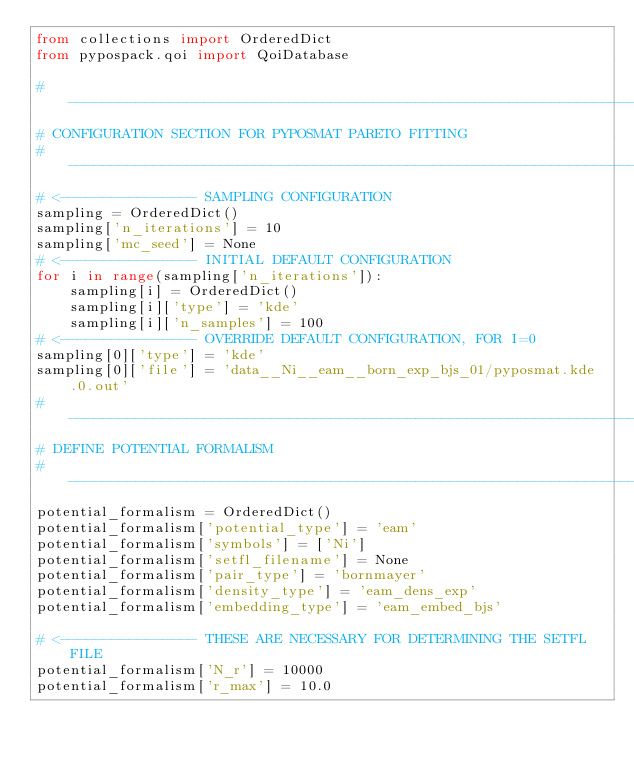<code> <loc_0><loc_0><loc_500><loc_500><_Python_>from collections import OrderedDict
from pypospack.qoi import QoiDatabase

#------------------------------------------------------------------------------
# CONFIGURATION SECTION FOR PYPOSMAT PARETO FITTING
#------------------------------------------------------------------------------
# <---------------- SAMPLING CONFIGURATION
sampling = OrderedDict()
sampling['n_iterations'] = 10
sampling['mc_seed'] = None
# <---------------- INITIAL DEFAULT CONFIGURATION
for i in range(sampling['n_iterations']):
    sampling[i] = OrderedDict()
    sampling[i]['type'] = 'kde'
    sampling[i]['n_samples'] = 100
# <---------------- OVERRIDE DEFAULT CONFIGURATION, FOR I=0
sampling[0]['type'] = 'kde'
sampling[0]['file'] = 'data__Ni__eam__born_exp_bjs_01/pyposmat.kde.0.out'
#-----------------------------------------------------------------------------
# DEFINE POTENTIAL FORMALISM
#-----------------------------------------------------------------------------
potential_formalism = OrderedDict()
potential_formalism['potential_type'] = 'eam'
potential_formalism['symbols'] = ['Ni']
potential_formalism['setfl_filename'] = None
potential_formalism['pair_type'] = 'bornmayer'
potential_formalism['density_type'] = 'eam_dens_exp'
potential_formalism['embedding_type'] = 'eam_embed_bjs'

# <---------------- THESE ARE NECESSARY FOR DETERMINING THE SETFL FILE
potential_formalism['N_r'] = 10000
potential_formalism['r_max'] = 10.0</code> 